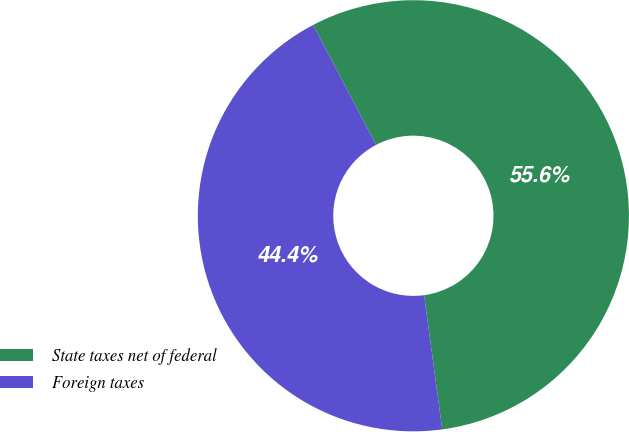Convert chart. <chart><loc_0><loc_0><loc_500><loc_500><pie_chart><fcel>State taxes net of federal<fcel>Foreign taxes<nl><fcel>55.56%<fcel>44.44%<nl></chart> 